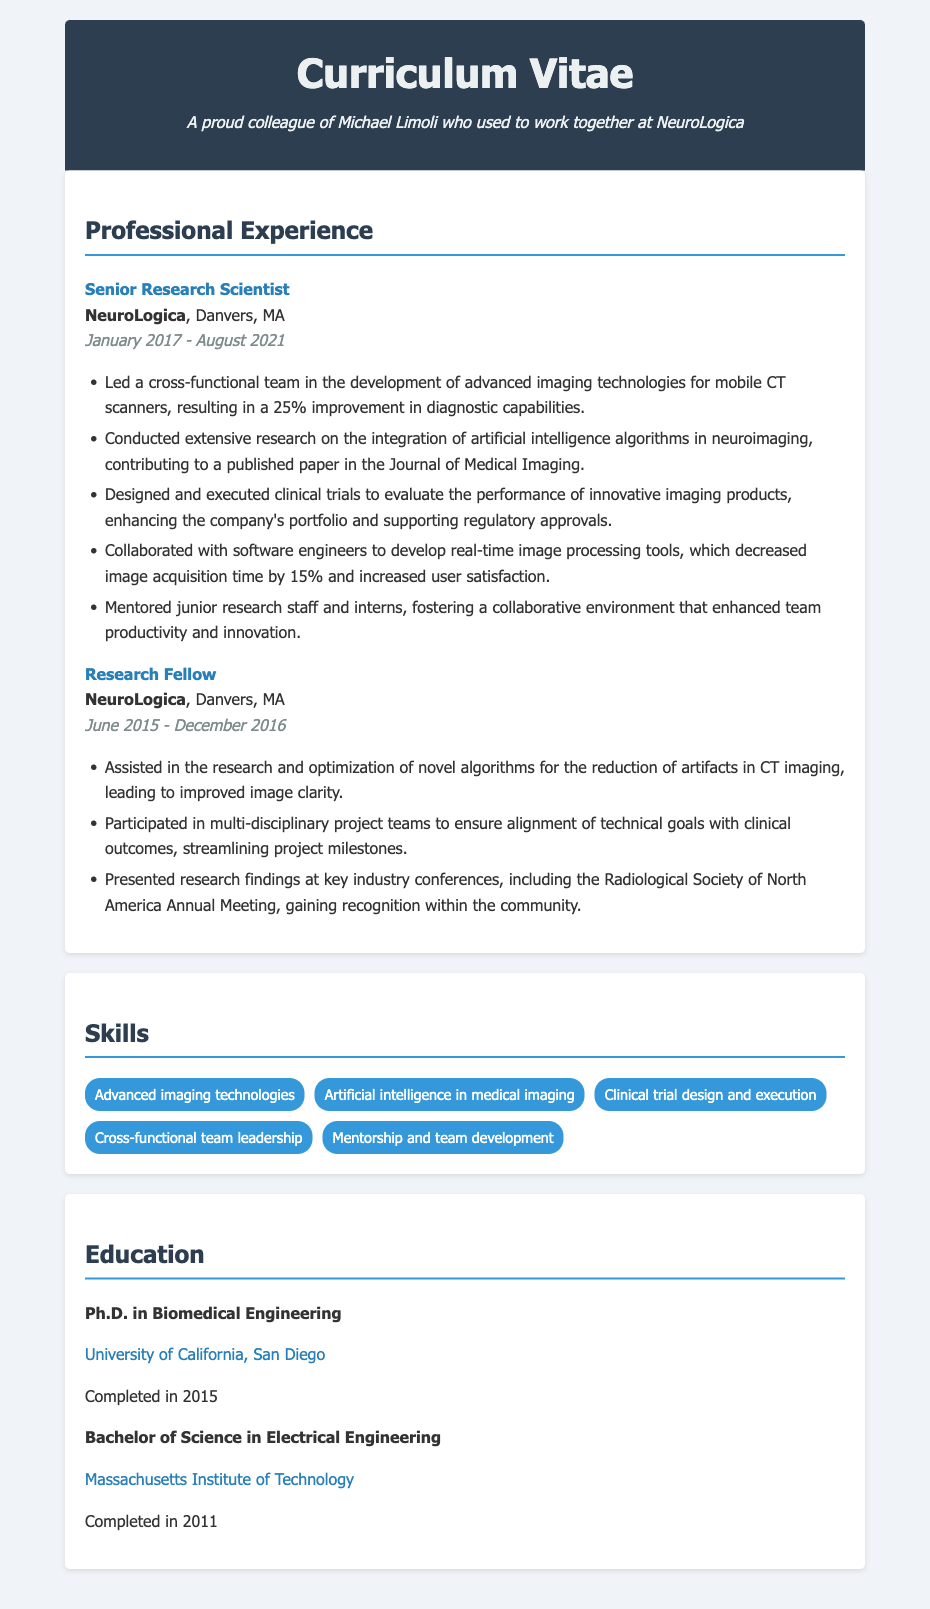what is Michael Limoli's role at NeuroLogica? Michael Limoli's role at NeuroLogica is as a Senior Research Scientist.
Answer: Senior Research Scientist when did Michael Limoli start working at NeuroLogica? Michael Limoli started working at NeuroLogica in January 2017.
Answer: January 2017 what was a key contribution of Michael Limoli during his time at NeuroLogica? A key contribution was leading a cross-functional team in the development of advanced imaging technologies for mobile CT scanners.
Answer: Advanced imaging technologies for mobile CT scanners how many years did Michael Limoli work at NeuroLogica? Michael Limoli worked at NeuroLogica from January 2017 to August 2021, totaling approximately 4 years.
Answer: 4 years which publication did Michael Limoli contribute to while at NeuroLogica? Michael Limoli contributed to a published paper in the Journal of Medical Imaging.
Answer: Journal of Medical Imaging what was the impact of the imaging technologies developed by Michael Limoli's team? The impact was a 25% improvement in diagnostic capabilities.
Answer: 25% improvement what degree did Michael Limoli earn in 2015? Michael Limoli earned a Ph.D. in Biomedical Engineering in 2015.
Answer: Ph.D. in Biomedical Engineering how did Michael Limoli contribute to team development at NeuroLogica? He mentored junior research staff and interns, fostering a collaborative environment.
Answer: Mentored junior research staff and interns what type of trials did Michael Limoli design and execute? He designed and executed clinical trials to evaluate the performance of innovative imaging products.
Answer: Clinical trials 